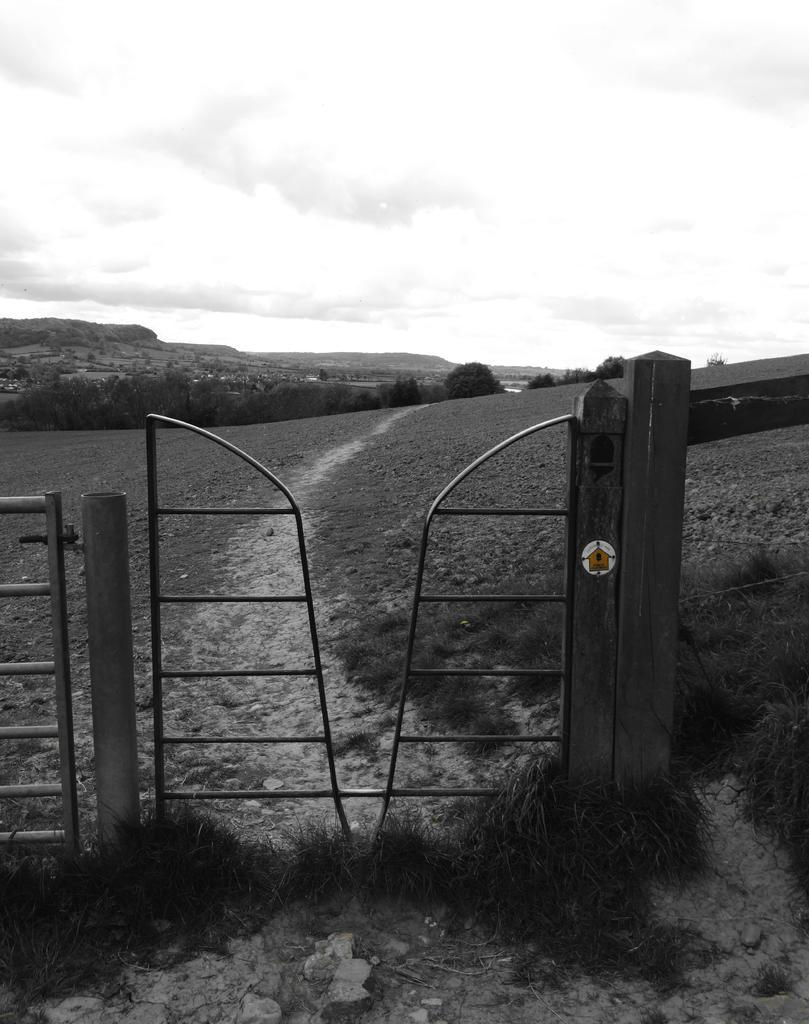What type of vegetation is in the center of the image? There is grass in the center of the image. What structure is also present in the center of the image? There is a fence in the center of the image. What can be seen in the background of the image? The sky, clouds, hills, and trees are visible in the background of the image. What color is the crayon used to draw the hills in the image? There is no crayon present in the image; the hills are depicted as part of the natural landscape. How many toes are visible in the image? There are no visible toes in the image. 